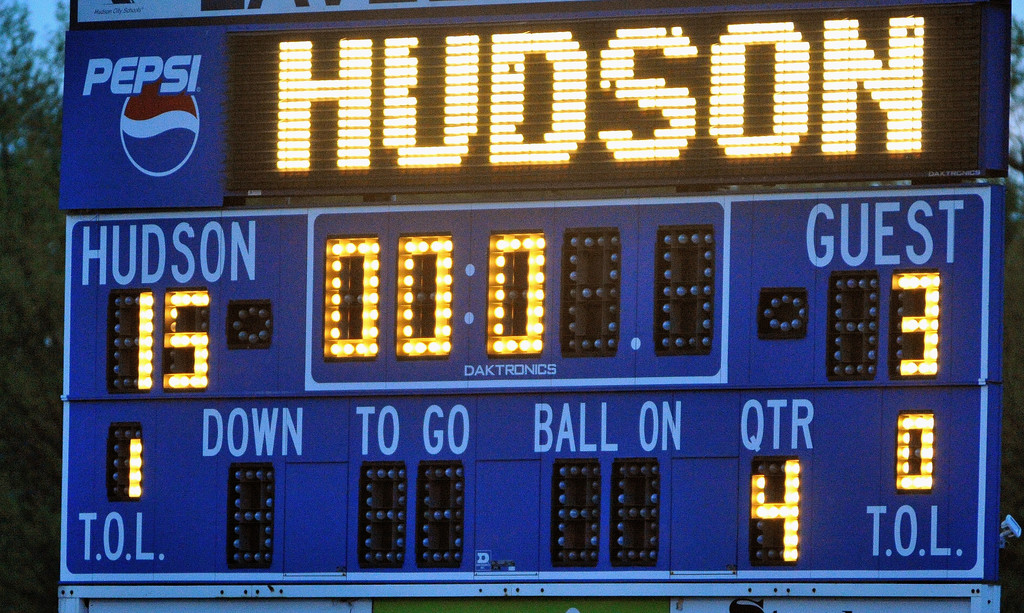Write a detailed description of the given image.
 The image captures a moment of triumph for the guest team at a football game, as displayed on a Pepsi-sponsored Daktronics scoreboard. The final score stands at 33-18 in favor of the guest team, marking their victory. The scoreboard also provides additional game details such as the down, yards to go, ball on, quarter, and time outs left, offering a comprehensive overview of the game's progress and outcome. 